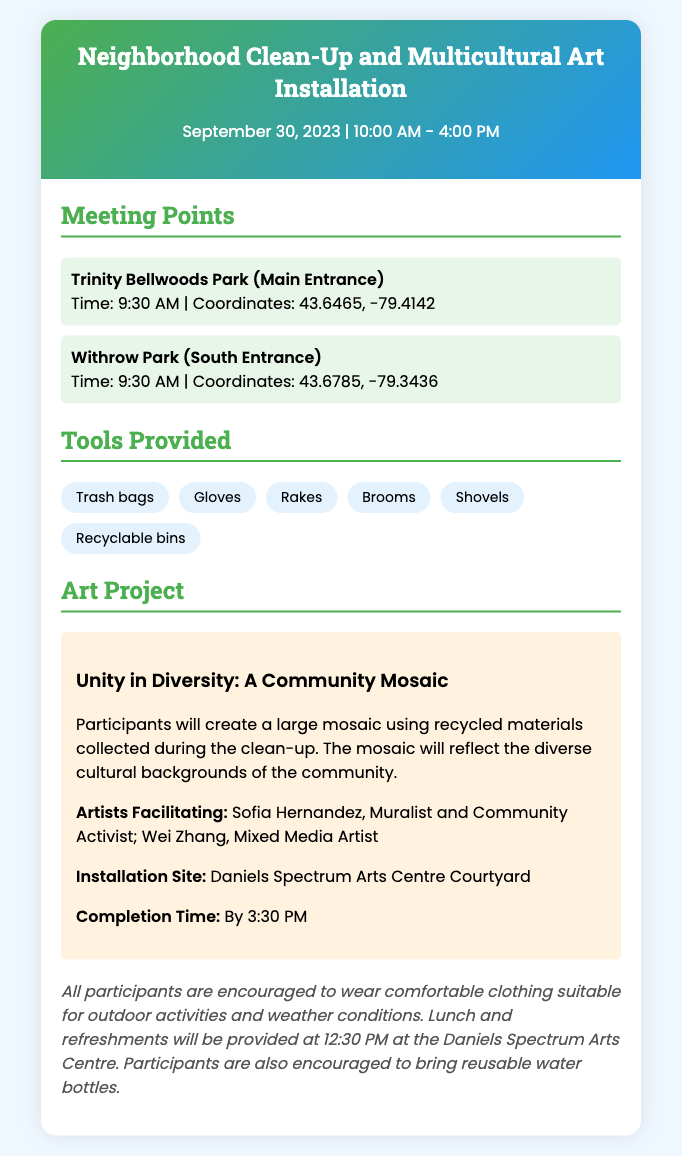What is the date of the event? The event is scheduled for September 30, 2023.
Answer: September 30, 2023 What are the coordinates for Trinity Bellwoods Park? The coordinates for Trinity Bellwoods Park are provided in the meeting point section.
Answer: 43.6465, -79.4142 What tools are provided for the clean-up? The tools provided include items necessary for the clean-up, listed under the tools section.
Answer: Trash bags, Gloves, Rakes, Brooms, Shovels, Recyclable bins Who are the artists facilitating the art project? The document mentions the names of the artists facilitating the community mosaic art project.
Answer: Sofia Hernandez, Wei Zhang What is the title of the art project? The title of the art project is highlighted in the art project section of the document.
Answer: Unity in Diversity: A Community Mosaic What time will lunch be provided? The document specifies when lunch will be given to participants during the event.
Answer: 12:30 PM What is the completion time of the art installation? The completion time for the art installation is indicated in the art project section.
Answer: By 3:30 PM What should participants bring to the event? The document encourages participants to bring specific items for the event.
Answer: Reusable water bottles 